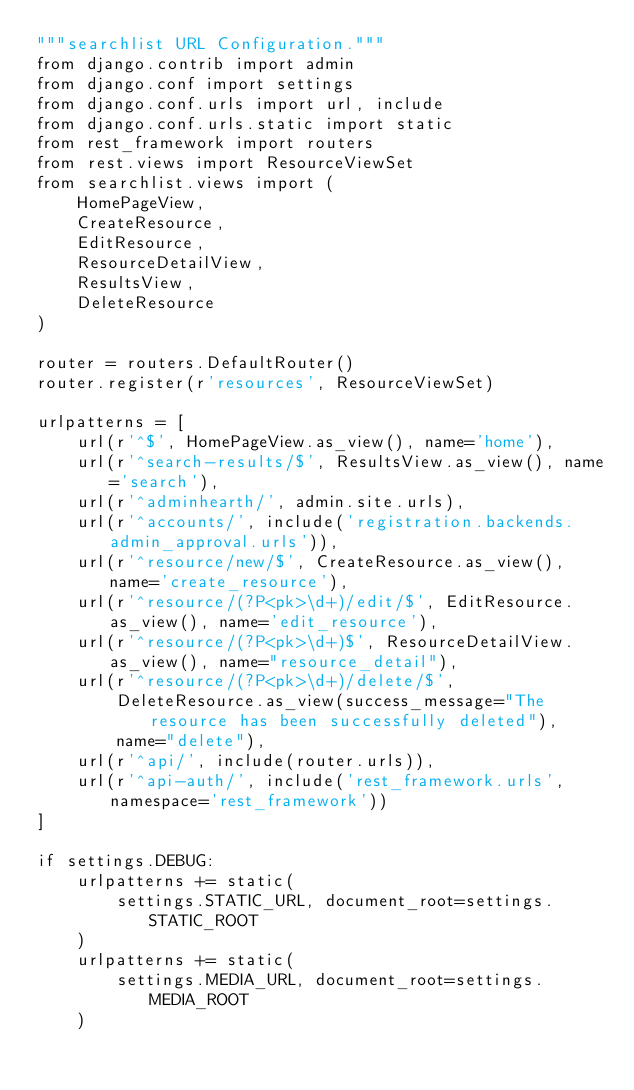<code> <loc_0><loc_0><loc_500><loc_500><_Python_>"""searchlist URL Configuration."""
from django.contrib import admin
from django.conf import settings
from django.conf.urls import url, include
from django.conf.urls.static import static
from rest_framework import routers
from rest.views import ResourceViewSet
from searchlist.views import (
    HomePageView,
    CreateResource,
    EditResource,
    ResourceDetailView,
    ResultsView,
    DeleteResource
)

router = routers.DefaultRouter()
router.register(r'resources', ResourceViewSet)

urlpatterns = [
    url(r'^$', HomePageView.as_view(), name='home'),
    url(r'^search-results/$', ResultsView.as_view(), name='search'),
    url(r'^adminhearth/', admin.site.urls),
    url(r'^accounts/', include('registration.backends.admin_approval.urls')),
    url(r'^resource/new/$', CreateResource.as_view(), name='create_resource'),
    url(r'^resource/(?P<pk>\d+)/edit/$', EditResource.as_view(), name='edit_resource'),
    url(r'^resource/(?P<pk>\d+)$', ResourceDetailView.as_view(), name="resource_detail"),
    url(r'^resource/(?P<pk>\d+)/delete/$',
        DeleteResource.as_view(success_message="The resource has been successfully deleted"),
        name="delete"),
    url(r'^api/', include(router.urls)),
    url(r'^api-auth/', include('rest_framework.urls', namespace='rest_framework'))
]

if settings.DEBUG:
    urlpatterns += static(
        settings.STATIC_URL, document_root=settings.STATIC_ROOT
    )
    urlpatterns += static(
        settings.MEDIA_URL, document_root=settings.MEDIA_ROOT
    )
</code> 